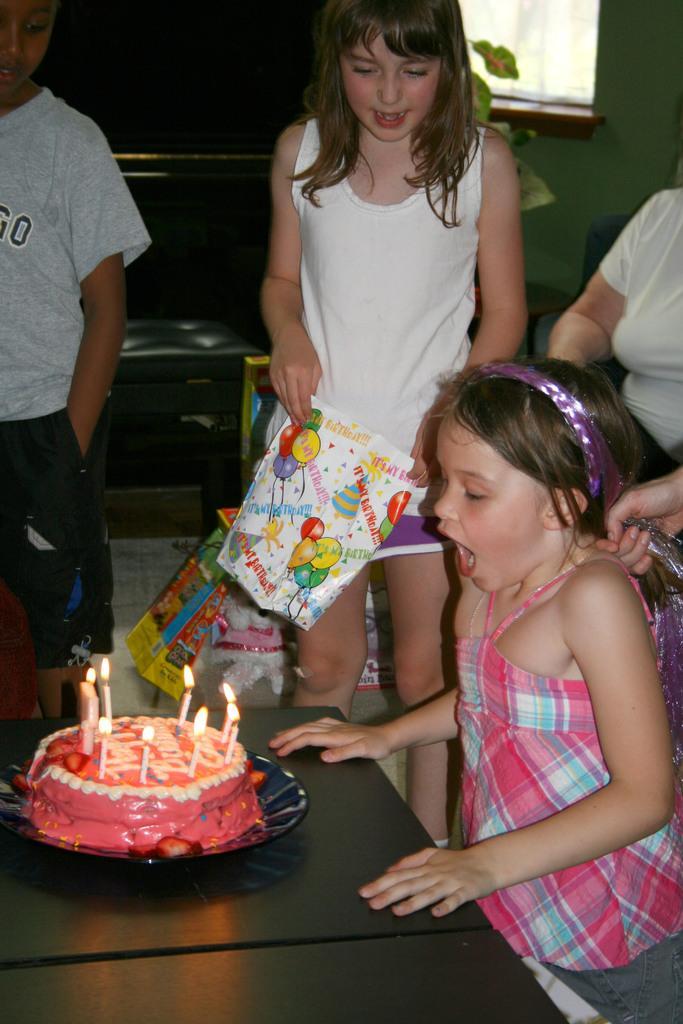In one or two sentences, can you explain what this image depicts? In this image we can see a few people and there is a girl and we can see a table in front of her and on the table we can see a cake. We can see some other objects in the room. 